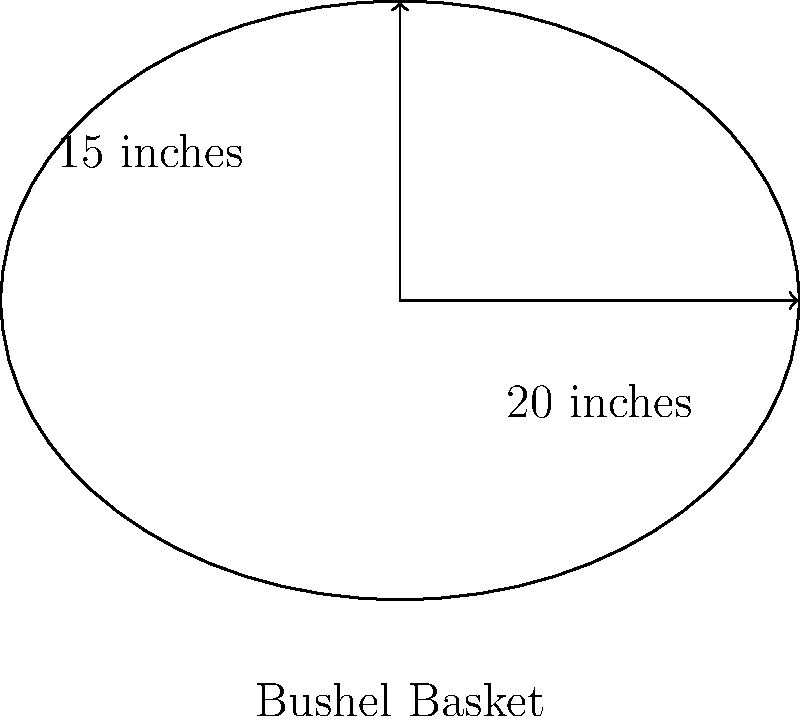A local farmer claims that his bushel basket can hold about 125 apples. Given that the basket is shaped like half an ellipsoid with a diameter of 20 inches and a depth of 15 inches, estimate how many medium-sized apples (approximately 3 inches in diameter) the basket can actually hold. Is the farmer's claim reasonable? Let's approach this step-by-step using simple arithmetic:

1) First, we need to estimate the volume of the bushel basket:
   - The basket is shaped like half an ellipsoid
   - Volume of half an ellipsoid = $\frac{2}{3} \pi a b c$, where $a$, $b$, and $c$ are the semi-axes

2) Calculate the semi-axes:
   - $a = b = 10$ inches (half of 20 inches diameter)
   - $c = 15$ inches (depth)

3) Calculate the volume:
   $V = \frac{2}{3} \pi (10)(10)(15) = 1000\pi \approx 3141.59$ cubic inches

4) Now, let's estimate the volume of a medium-sized apple:
   - Assuming a spherical shape with 3 inches diameter
   - Volume of a sphere = $\frac{4}{3} \pi r^3$
   - $r = 1.5$ inches
   - Apple volume = $\frac{4}{3} \pi (1.5)^3 \approx 14.14$ cubic inches

5) Estimate number of apples:
   - Number of apples = Basket volume / Apple volume
   - $3141.59 / 14.14 \approx 222$ apples

6) Consider packing efficiency:
   - Spheres don't pack perfectly, typically around 74% efficiency
   - $222 * 0.74 \approx 164$ apples

Therefore, the basket can hold approximately 164 medium-sized apples. The farmer's claim of 125 apples is reasonable and even conservative, likely accounting for variations in apple sizes and imperfect packing.
Answer: Approximately 164 apples; farmer's claim is reasonable. 